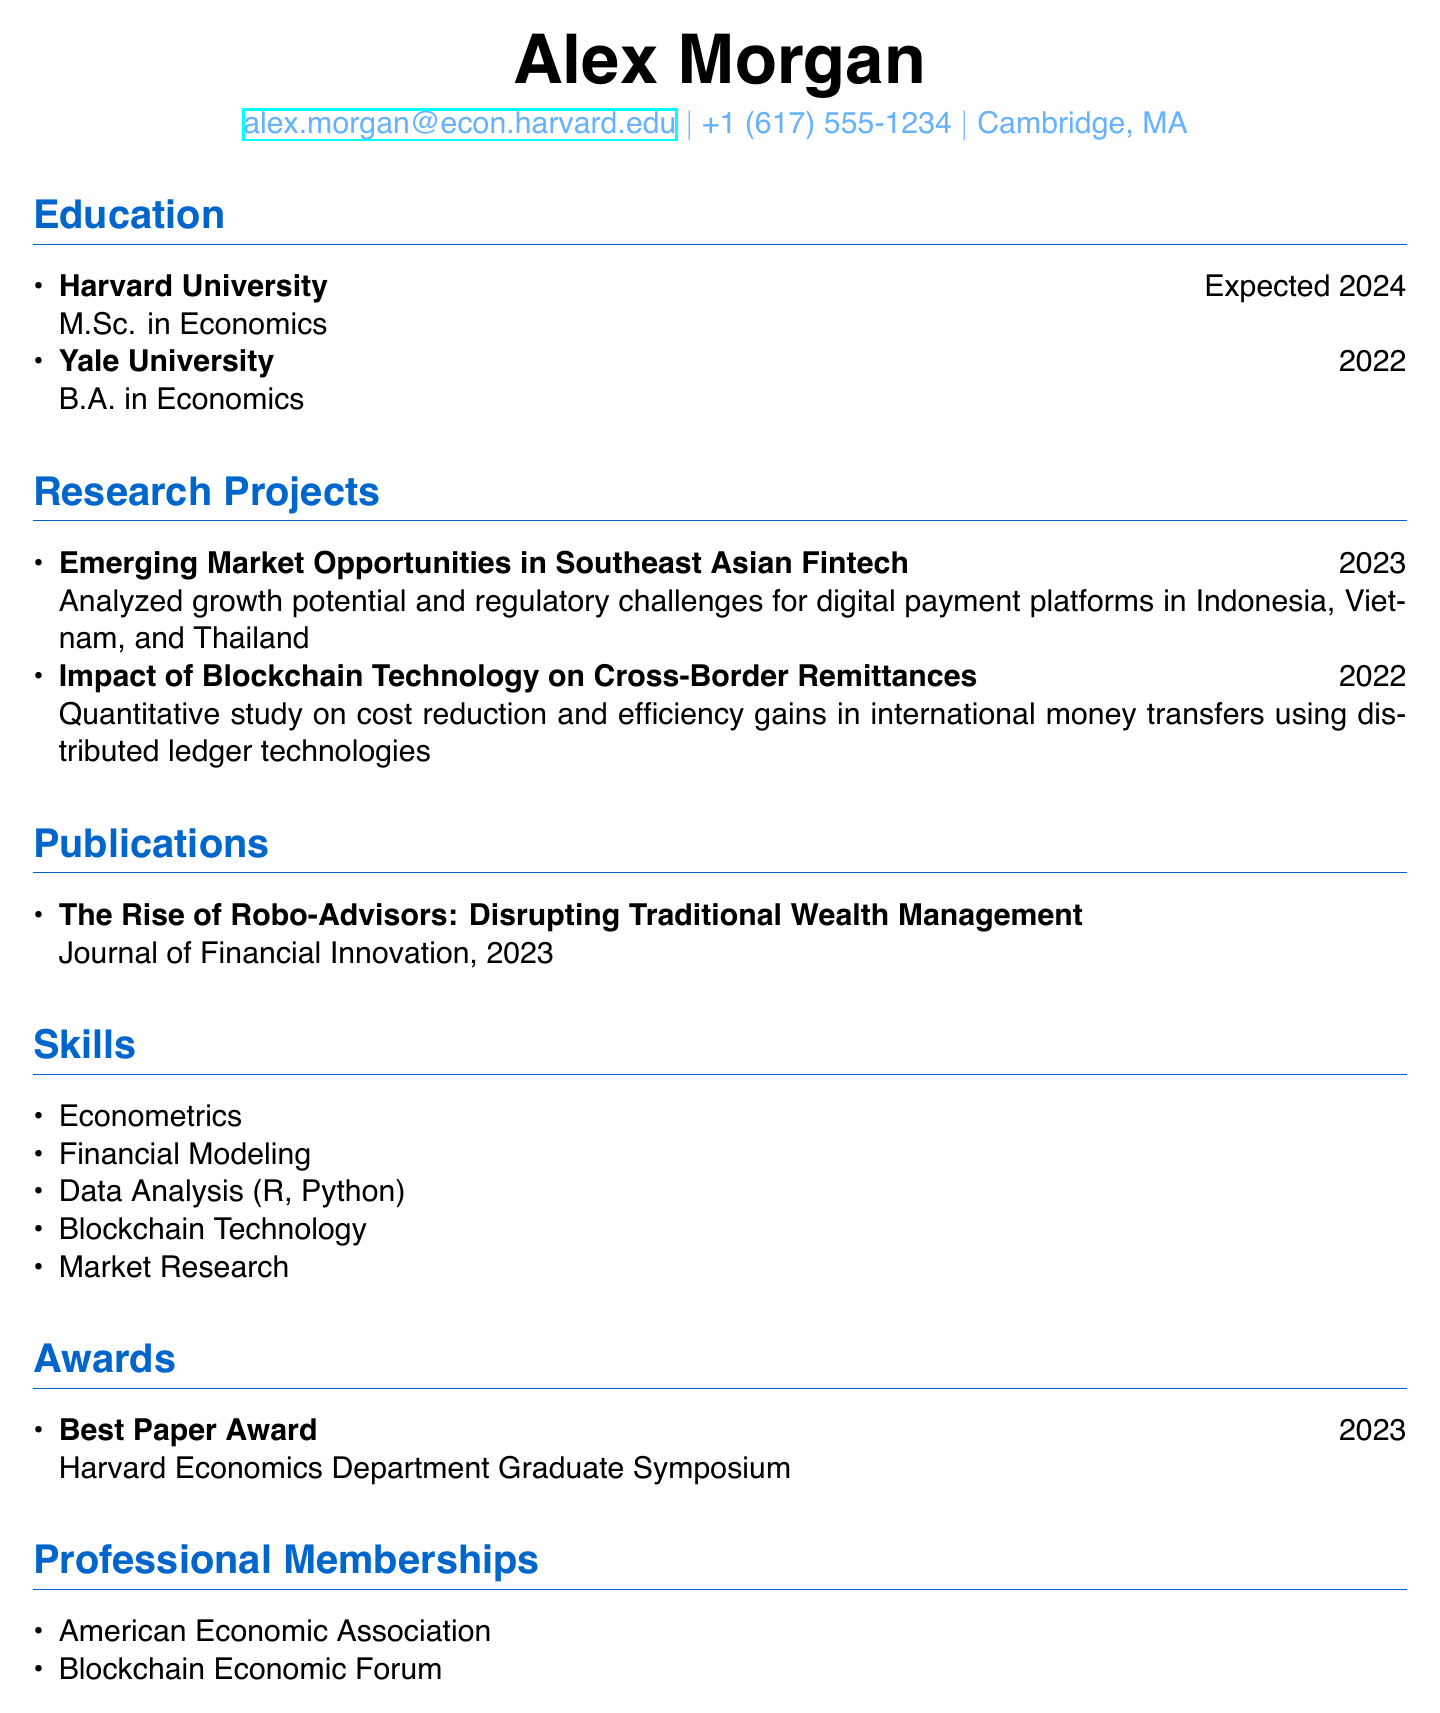What is the expected graduation year for the M.Sc. in Economics? The expected graduation year is mentioned in the education section under Harvard University.
Answer: 2024 Who conducted the research project on emerging market opportunities in fintech? The research project listed in the document is conducted by Alex Morgan.
Answer: Alex Morgan What is the title of the publication in the Journal of Financial Innovation? The title of the publication is listed under the publications section.
Answer: The Rise of Robo-Advisors: Disrupting Traditional Wealth Management What award did Alex Morgan receive in 2023? The award section specifies the award granted in 2023 was the Best Paper Award.
Answer: Best Paper Award Which skill related to data analysis is mentioned in the skills section? The skills section includes various data analysis techniques.
Answer: Data Analysis (R, Python) In which organization is Alex Morgan a professional member? The professional memberships section lists organizations pertaining to Alex Morgan's memberships.
Answer: American Economic Association What was the focus of the research project conducted in 2022? The description of the research project focuses on blockchain technology and its benefits.
Answer: Cost reduction and efficiency gains in international money transfers How many research projects are listed in total? The total count of research projects is derived from the research projects section.
Answer: 2 